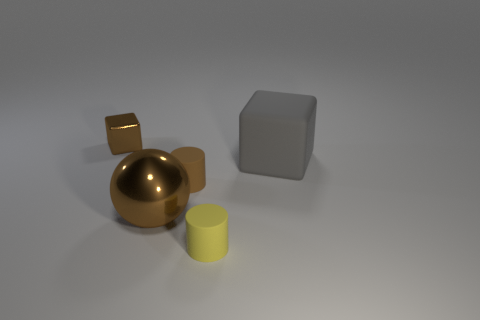What materials do the objects in the image look like they're made of? The objects appear to consist of different materials. The large gray cube seems matte, possibly concrete or stone. The golden sphere and smaller cube give off a reflective sheen, suggesting they are made of polished metal, while the smaller yellow cylinder looks like it could be made of plastic due to its less reflective surface. 